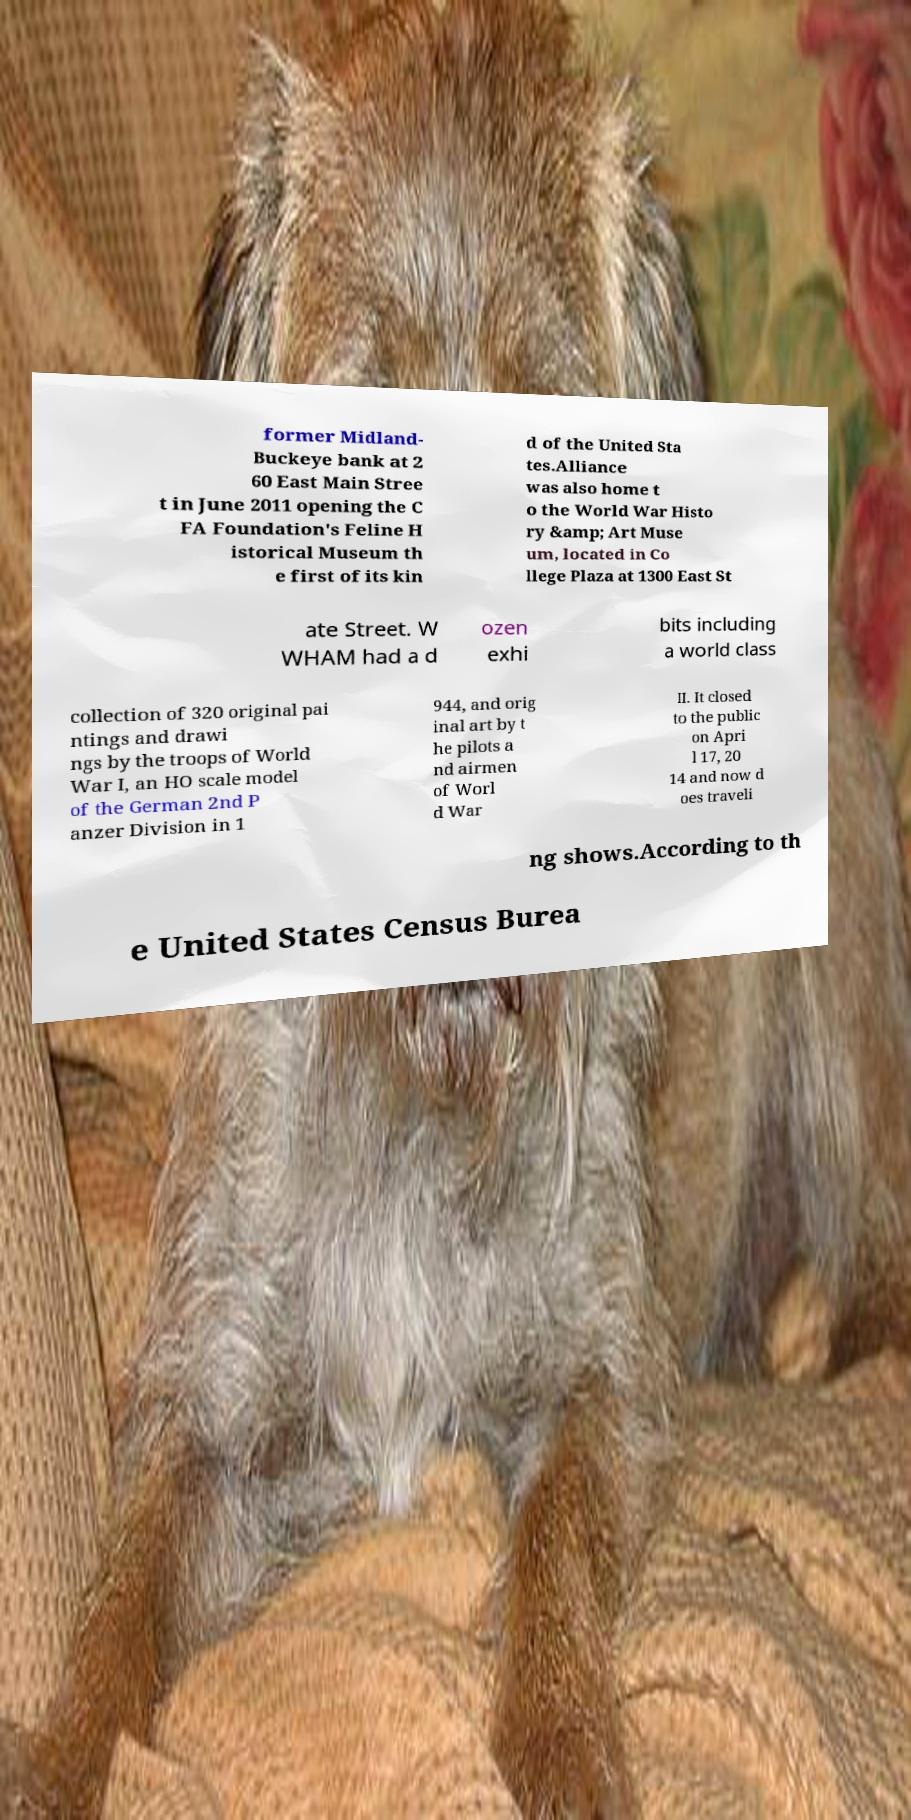Can you read and provide the text displayed in the image?This photo seems to have some interesting text. Can you extract and type it out for me? former Midland- Buckeye bank at 2 60 East Main Stree t in June 2011 opening the C FA Foundation's Feline H istorical Museum th e first of its kin d of the United Sta tes.Alliance was also home t o the World War Histo ry &amp; Art Muse um, located in Co llege Plaza at 1300 East St ate Street. W WHAM had a d ozen exhi bits including a world class collection of 320 original pai ntings and drawi ngs by the troops of World War I, an HO scale model of the German 2nd P anzer Division in 1 944, and orig inal art by t he pilots a nd airmen of Worl d War II. It closed to the public on Apri l 17, 20 14 and now d oes traveli ng shows.According to th e United States Census Burea 